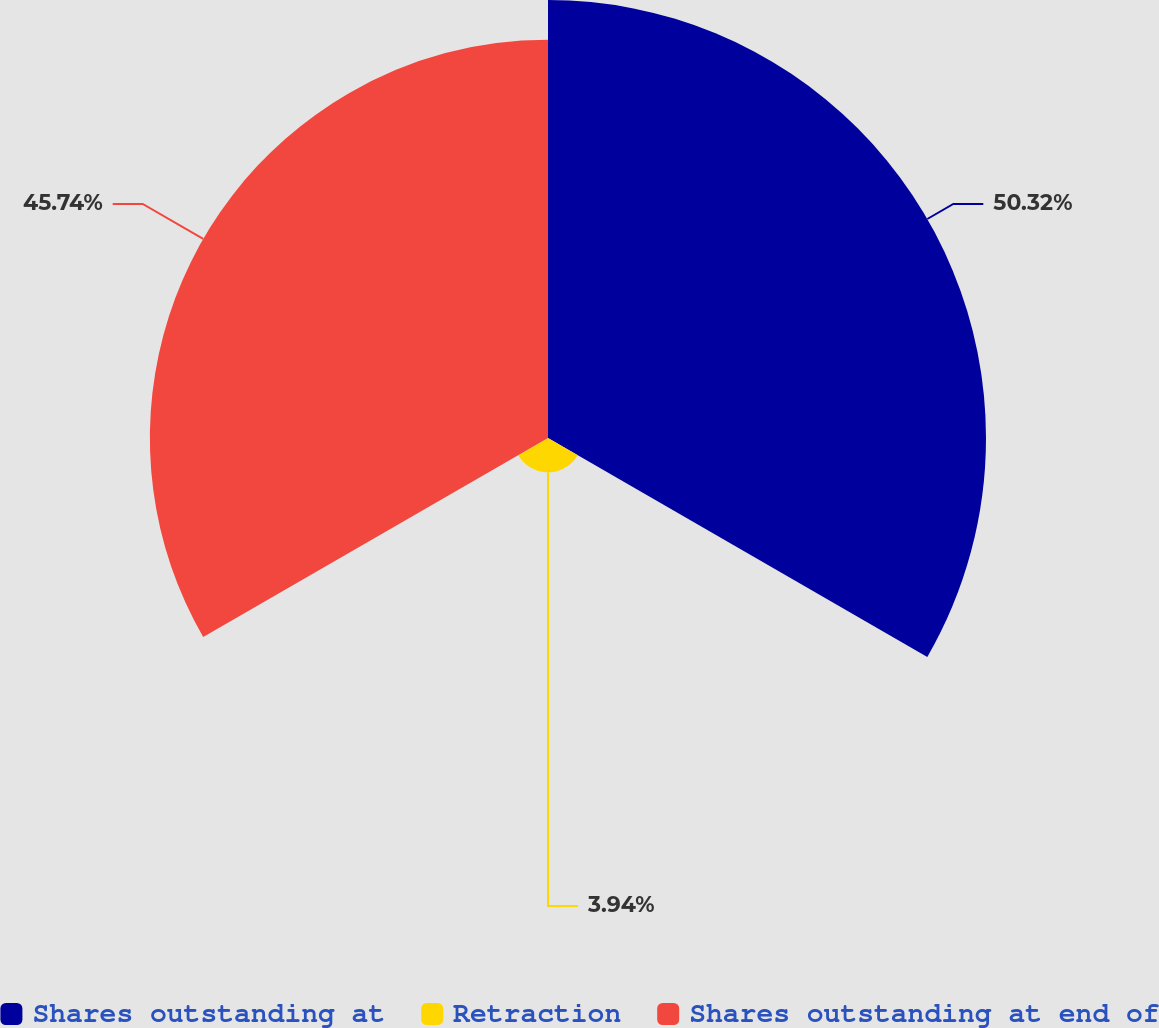Convert chart to OTSL. <chart><loc_0><loc_0><loc_500><loc_500><pie_chart><fcel>Shares outstanding at<fcel>Retraction<fcel>Shares outstanding at end of<nl><fcel>50.32%<fcel>3.94%<fcel>45.74%<nl></chart> 